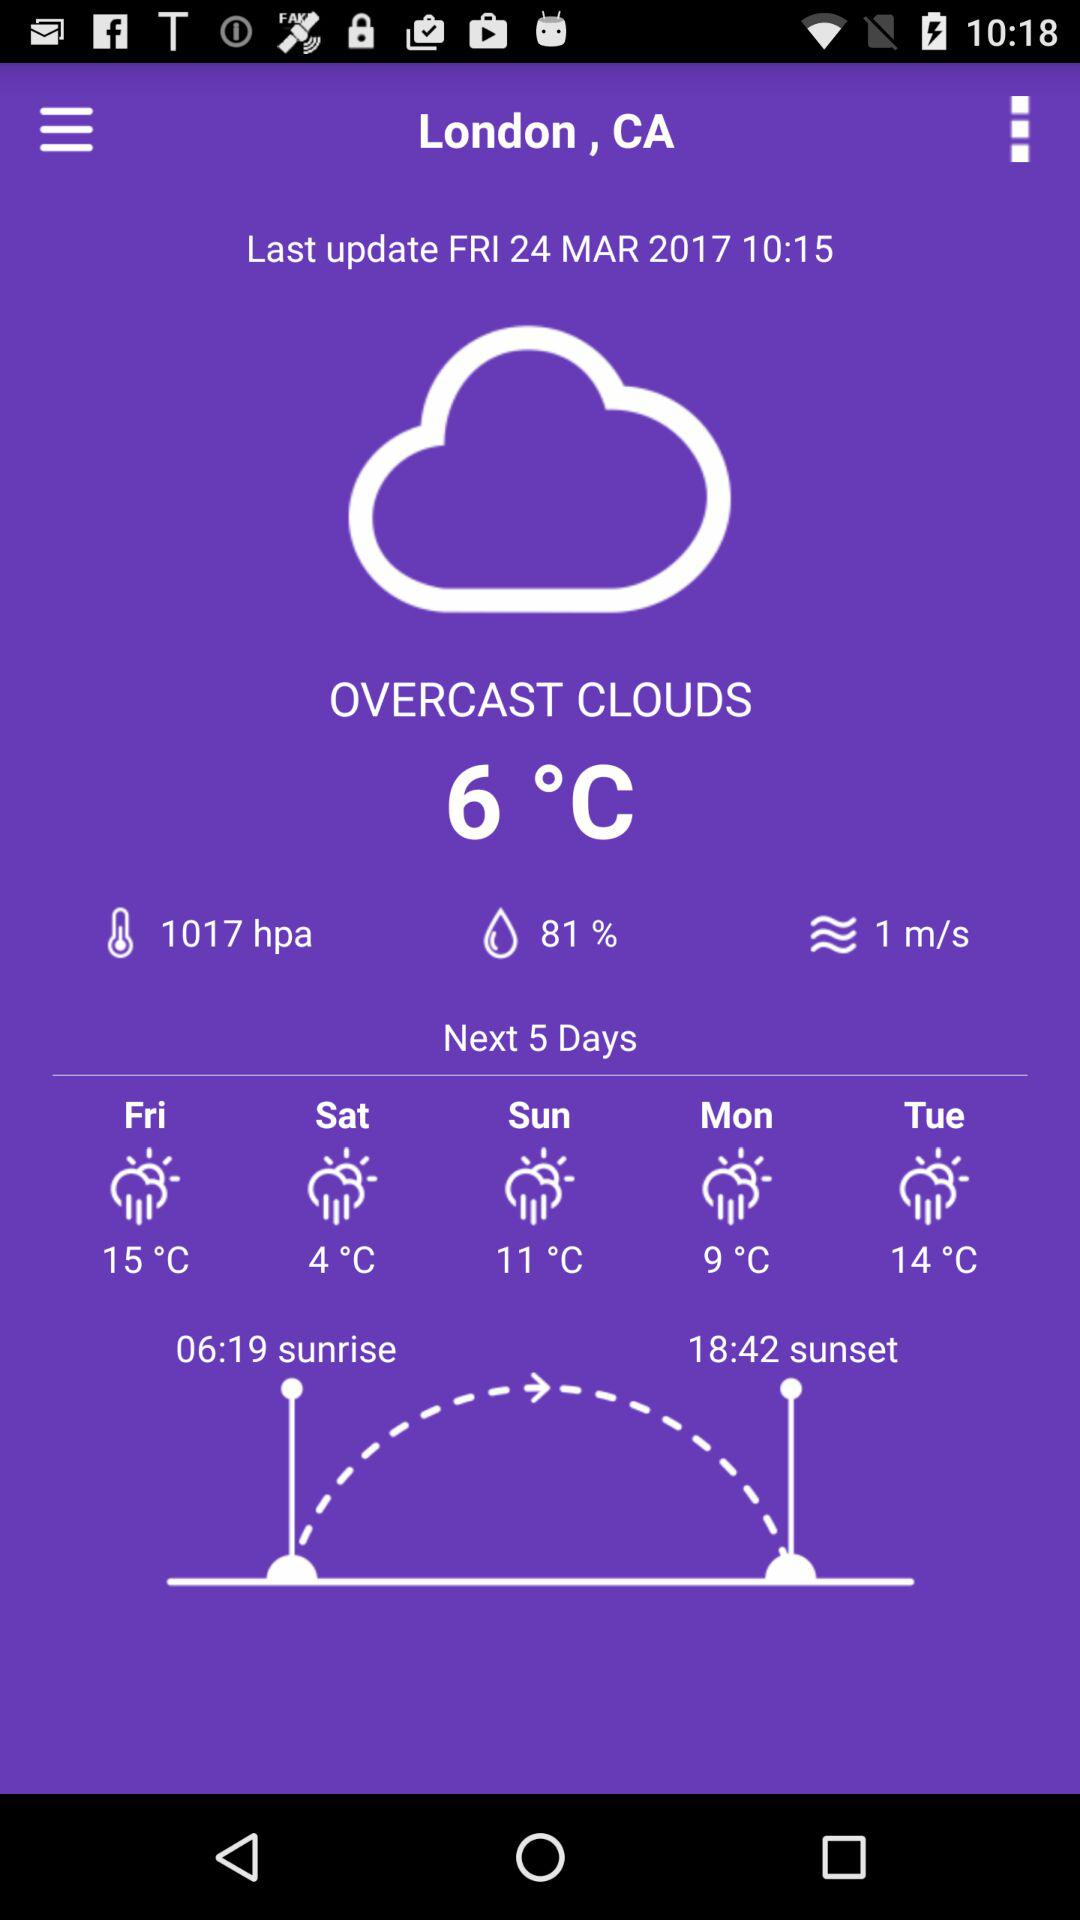What is the unit of temperature? The unit of temperature is degree Celsius. 